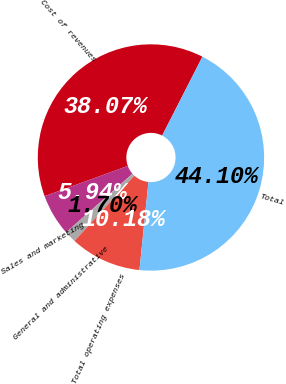Convert chart. <chart><loc_0><loc_0><loc_500><loc_500><pie_chart><fcel>Cost of revenues<fcel>Sales and marketing<fcel>General and administrative<fcel>Total operating expenses<fcel>Total<nl><fcel>38.07%<fcel>5.94%<fcel>1.7%<fcel>10.18%<fcel>44.1%<nl></chart> 